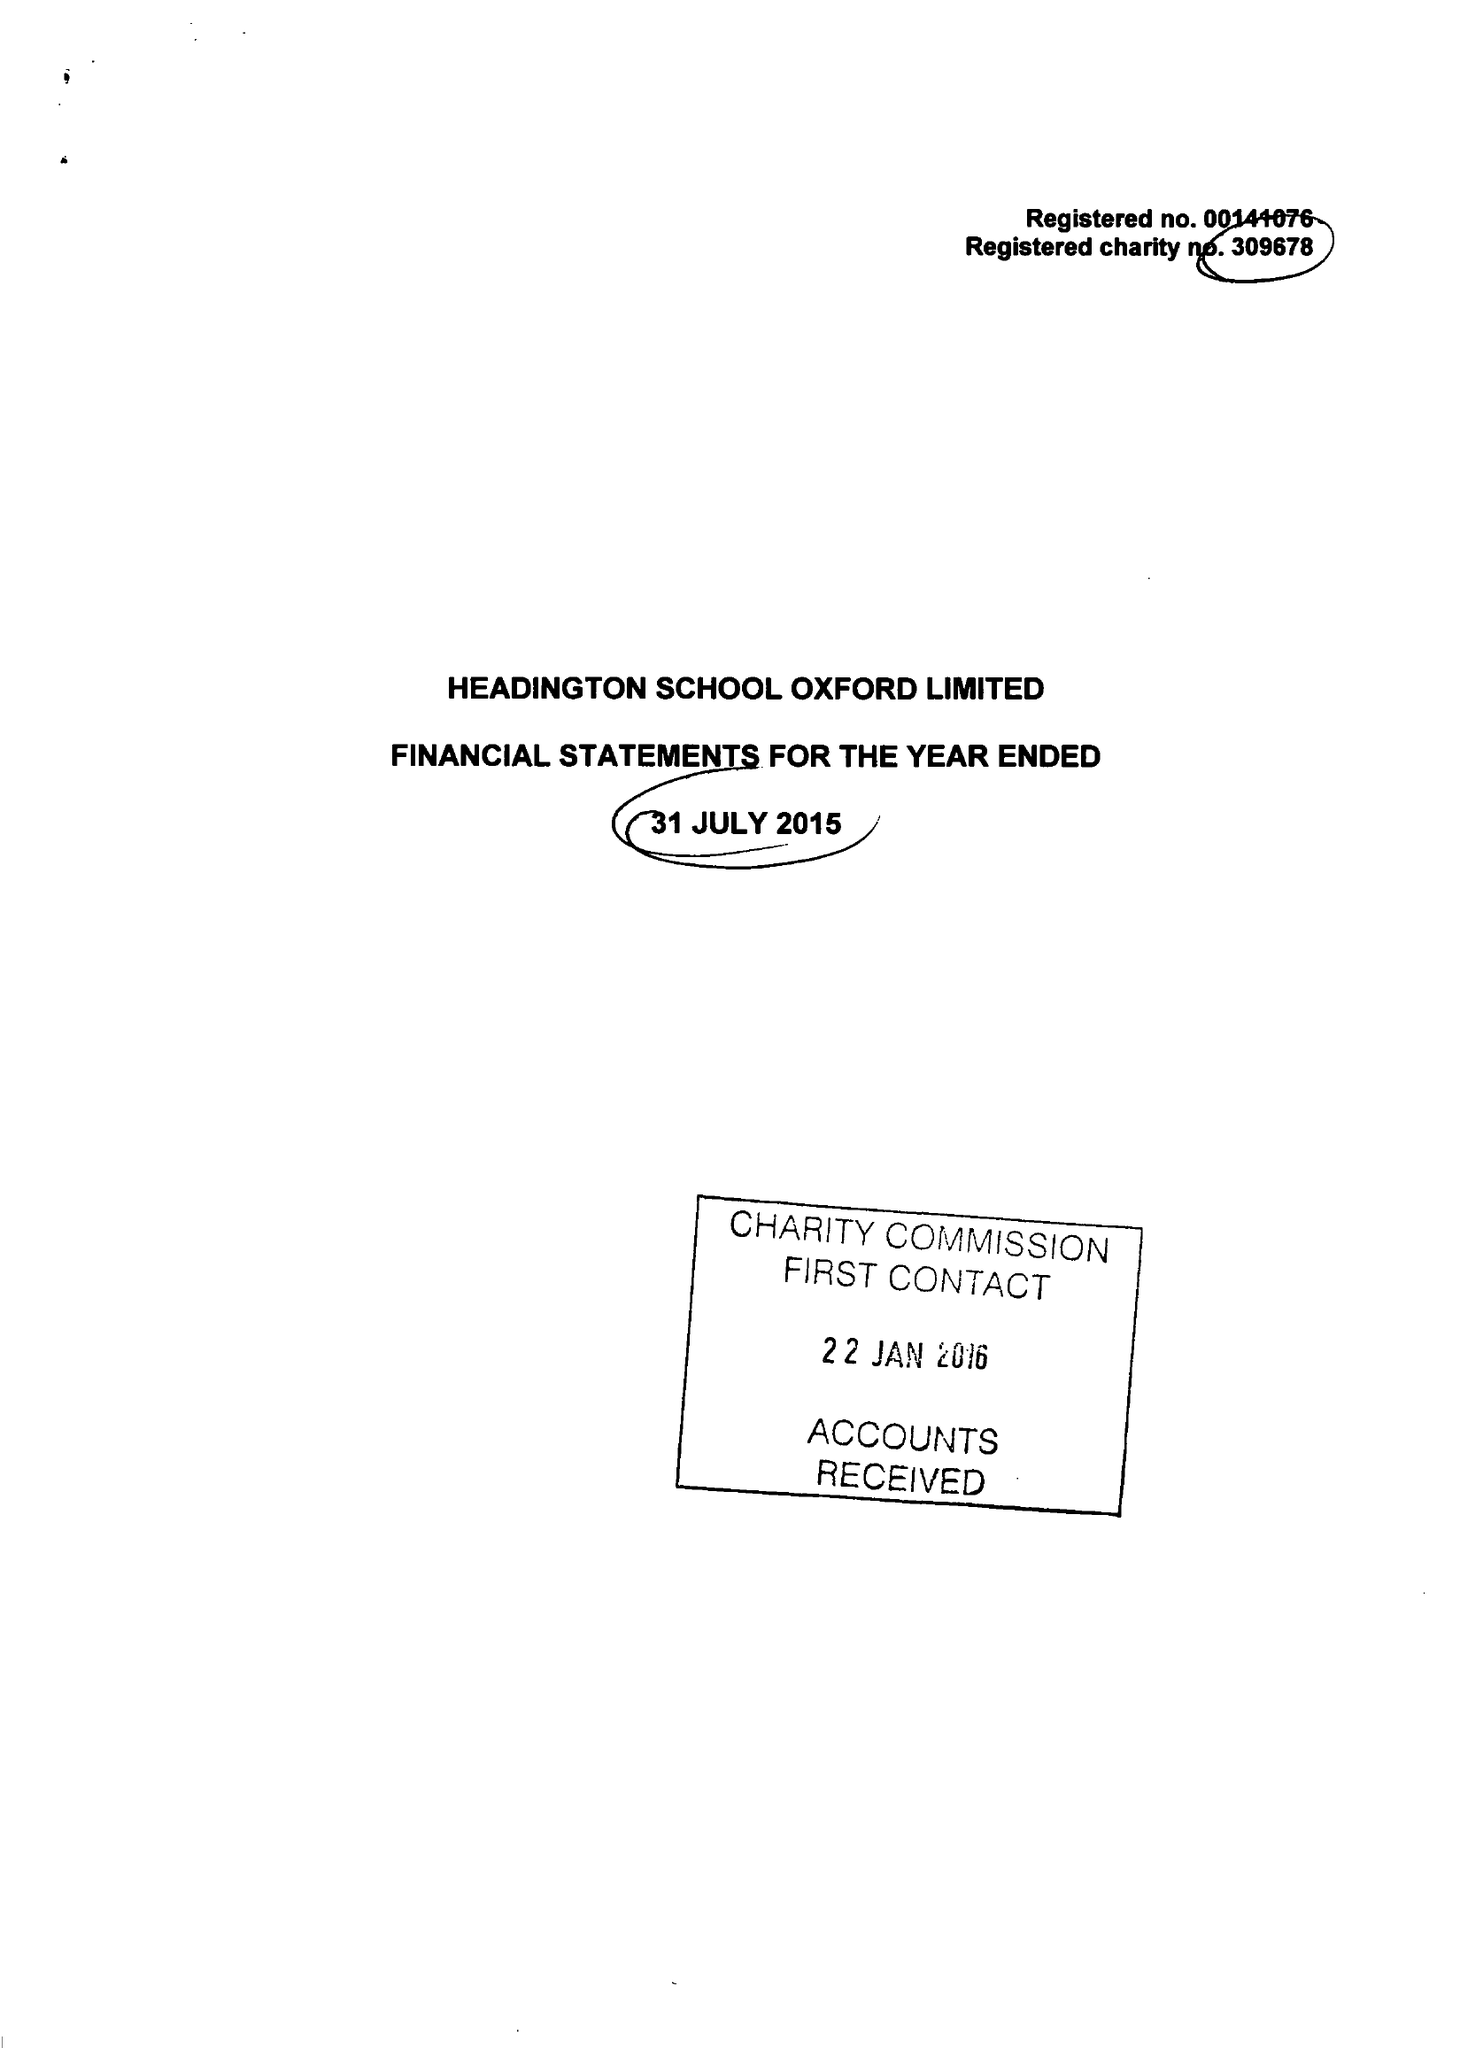What is the value for the address__street_line?
Answer the question using a single word or phrase. HEADINGTON ROAD 